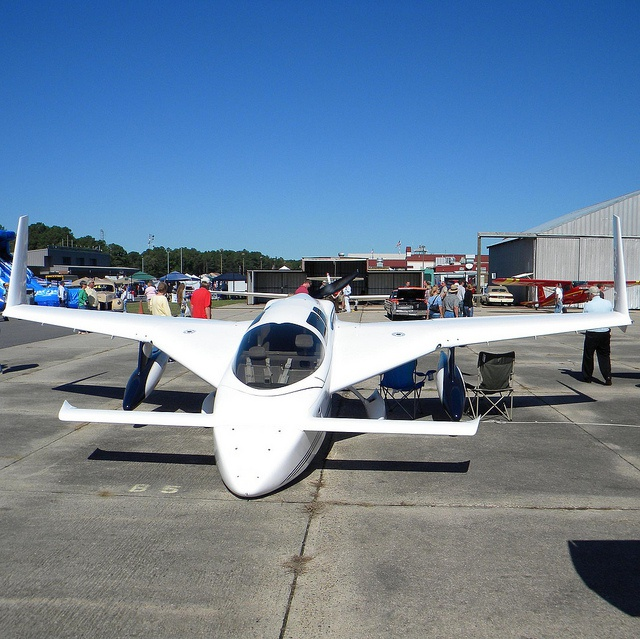Describe the objects in this image and their specific colors. I can see airplane in blue, white, gray, darkgray, and black tones, chair in blue, black, gray, and darkgray tones, airplane in blue, maroon, black, brown, and gray tones, people in blue, black, gray, lightgray, and darkgray tones, and chair in blue, black, navy, gray, and darkgray tones in this image. 